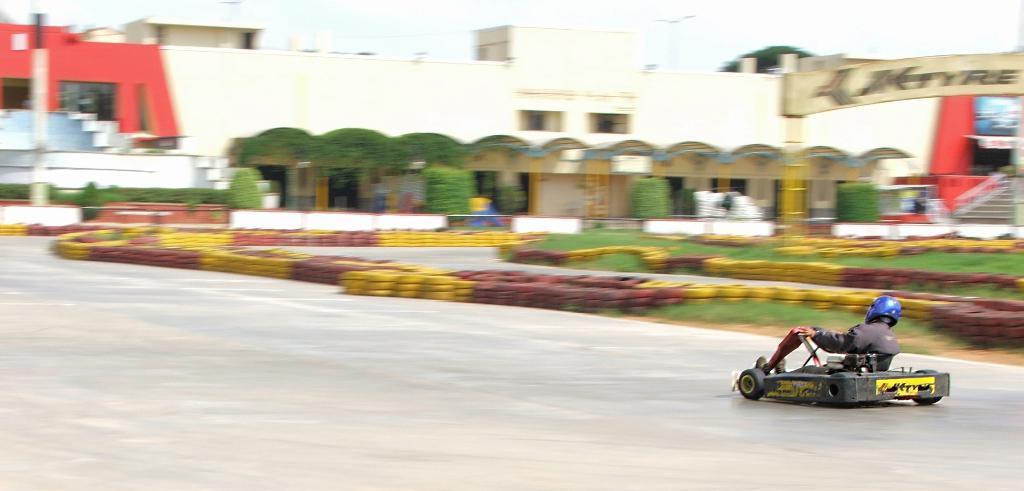Can you describe this image briefly? This image is taken indoors. At the bottom of the image there is a road. On the right side of the image a man is go-Karting. At the top of the image there is a building with a few walls, windows, doors, roofs and railings. There is a staircase and a board with text on it. In the middle of the image there are a few trees, plants and many tires. 